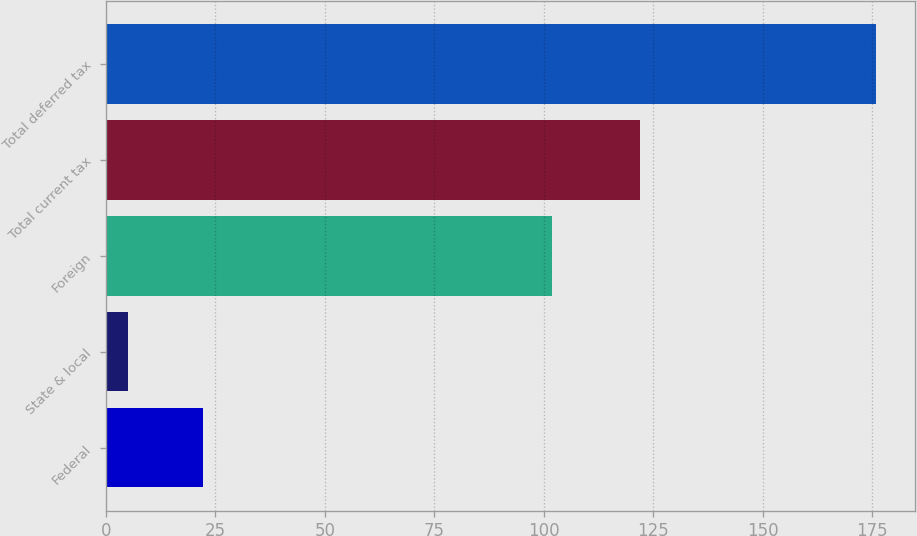Convert chart. <chart><loc_0><loc_0><loc_500><loc_500><bar_chart><fcel>Federal<fcel>State & local<fcel>Foreign<fcel>Total current tax<fcel>Total deferred tax<nl><fcel>22.1<fcel>5<fcel>102<fcel>122<fcel>176<nl></chart> 